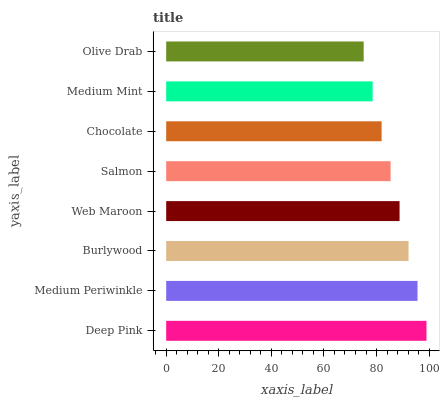Is Olive Drab the minimum?
Answer yes or no. Yes. Is Deep Pink the maximum?
Answer yes or no. Yes. Is Medium Periwinkle the minimum?
Answer yes or no. No. Is Medium Periwinkle the maximum?
Answer yes or no. No. Is Deep Pink greater than Medium Periwinkle?
Answer yes or no. Yes. Is Medium Periwinkle less than Deep Pink?
Answer yes or no. Yes. Is Medium Periwinkle greater than Deep Pink?
Answer yes or no. No. Is Deep Pink less than Medium Periwinkle?
Answer yes or no. No. Is Web Maroon the high median?
Answer yes or no. Yes. Is Salmon the low median?
Answer yes or no. Yes. Is Salmon the high median?
Answer yes or no. No. Is Olive Drab the low median?
Answer yes or no. No. 